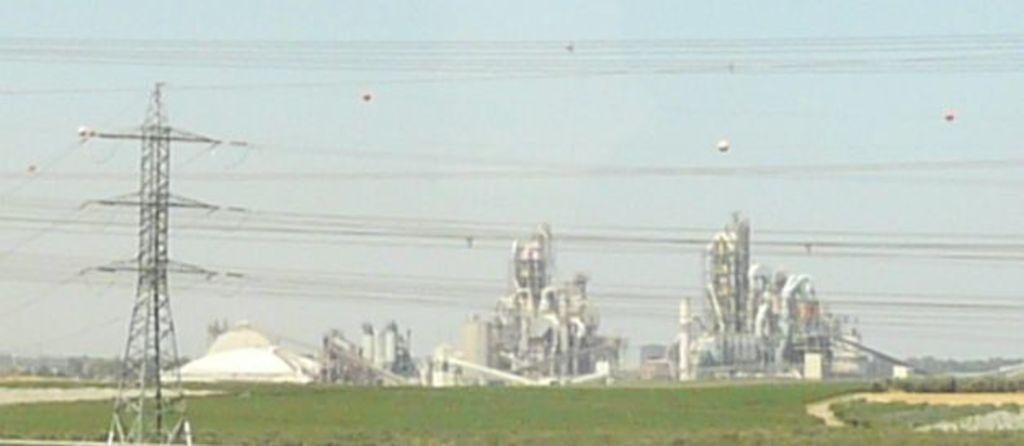What is the main structure in the image? There is a tower in the image. What else can be seen in the image besides the tower? Wires are visible in the image. What type of vegetation is in the background of the image? There is grass in the background of the image. What other structures can be seen in the background of the image? There are buildings in the background of the image. What is the condition of the sky in the image? The sky is clear and visible in the image. How many nails can be seen in the image? There are no nails present in the image. 